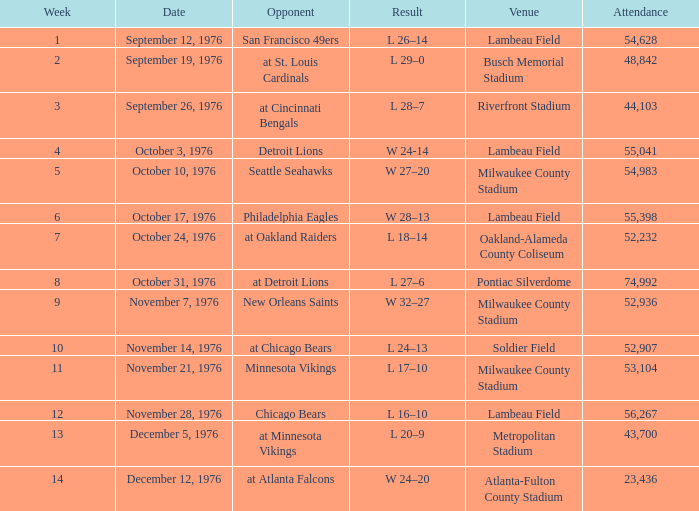During which week number did they have their first game against the detroit lions? 4.0. 